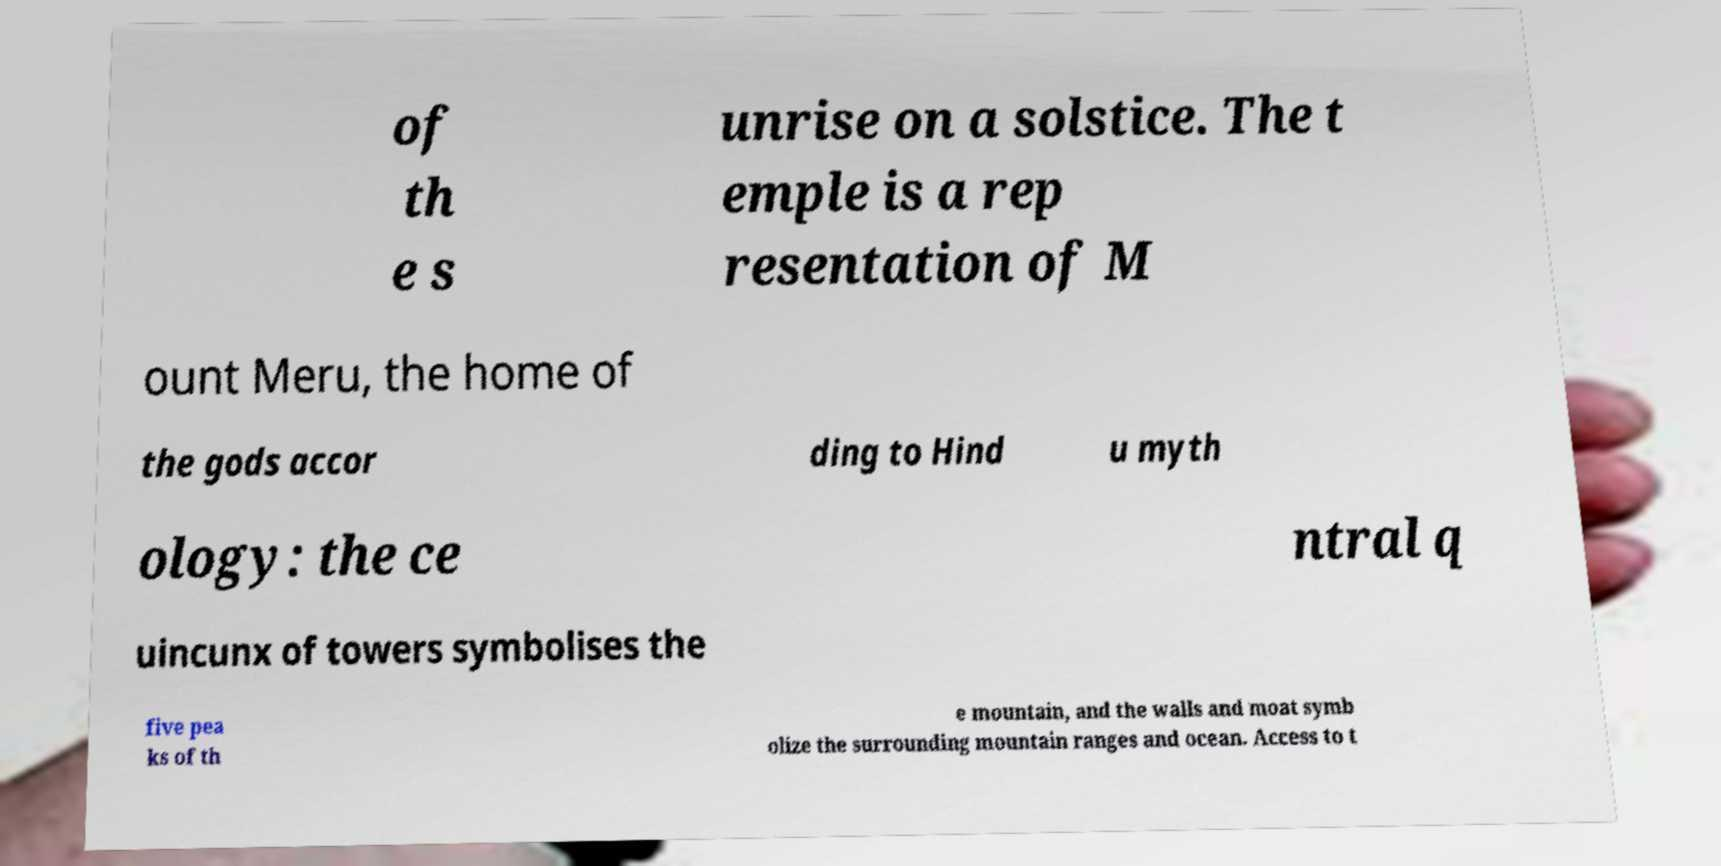What messages or text are displayed in this image? I need them in a readable, typed format. of th e s unrise on a solstice. The t emple is a rep resentation of M ount Meru, the home of the gods accor ding to Hind u myth ology: the ce ntral q uincunx of towers symbolises the five pea ks of th e mountain, and the walls and moat symb olize the surrounding mountain ranges and ocean. Access to t 